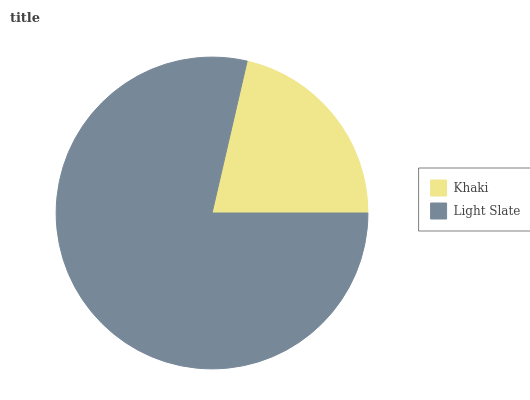Is Khaki the minimum?
Answer yes or no. Yes. Is Light Slate the maximum?
Answer yes or no. Yes. Is Light Slate the minimum?
Answer yes or no. No. Is Light Slate greater than Khaki?
Answer yes or no. Yes. Is Khaki less than Light Slate?
Answer yes or no. Yes. Is Khaki greater than Light Slate?
Answer yes or no. No. Is Light Slate less than Khaki?
Answer yes or no. No. Is Light Slate the high median?
Answer yes or no. Yes. Is Khaki the low median?
Answer yes or no. Yes. Is Khaki the high median?
Answer yes or no. No. Is Light Slate the low median?
Answer yes or no. No. 